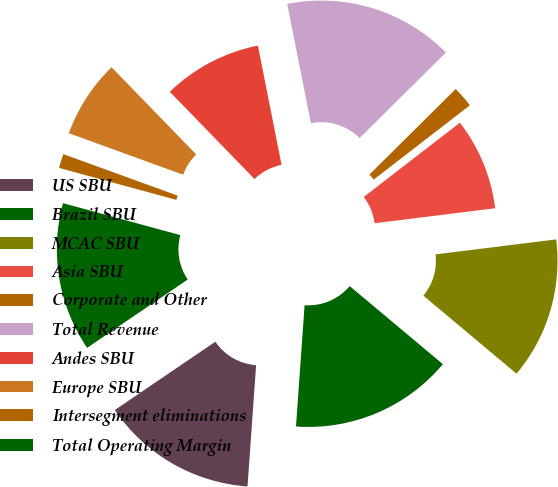Convert chart to OTSL. <chart><loc_0><loc_0><loc_500><loc_500><pie_chart><fcel>US SBU<fcel>Brazil SBU<fcel>MCAC SBU<fcel>Asia SBU<fcel>Corporate and Other<fcel>Total Revenue<fcel>Andes SBU<fcel>Europe SBU<fcel>Intersegment eliminations<fcel>Total Operating Margin<nl><fcel>14.38%<fcel>15.03%<fcel>13.07%<fcel>8.5%<fcel>1.96%<fcel>15.69%<fcel>9.15%<fcel>7.19%<fcel>1.31%<fcel>13.73%<nl></chart> 